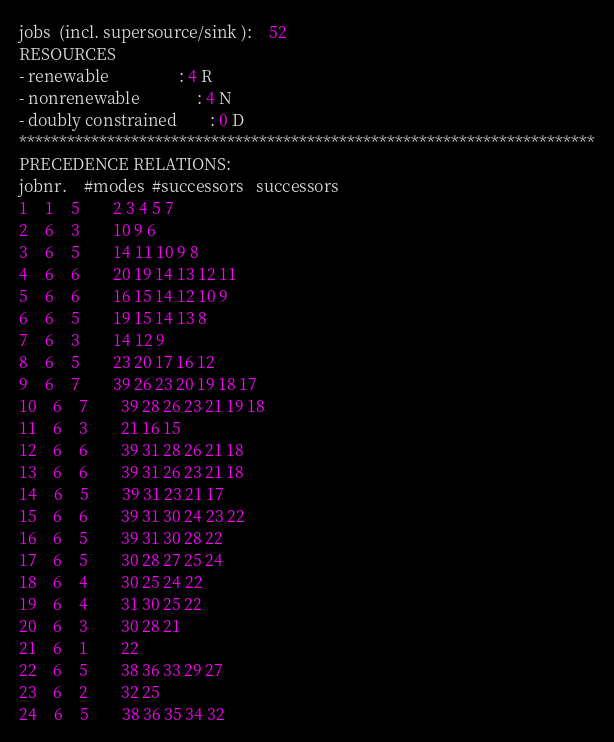<code> <loc_0><loc_0><loc_500><loc_500><_ObjectiveC_>jobs  (incl. supersource/sink ):	52
RESOURCES
- renewable                 : 4 R
- nonrenewable              : 4 N
- doubly constrained        : 0 D
************************************************************************
PRECEDENCE RELATIONS:
jobnr.    #modes  #successors   successors
1	1	5		2 3 4 5 7 
2	6	3		10 9 6 
3	6	5		14 11 10 9 8 
4	6	6		20 19 14 13 12 11 
5	6	6		16 15 14 12 10 9 
6	6	5		19 15 14 13 8 
7	6	3		14 12 9 
8	6	5		23 20 17 16 12 
9	6	7		39 26 23 20 19 18 17 
10	6	7		39 28 26 23 21 19 18 
11	6	3		21 16 15 
12	6	6		39 31 28 26 21 18 
13	6	6		39 31 26 23 21 18 
14	6	5		39 31 23 21 17 
15	6	6		39 31 30 24 23 22 
16	6	5		39 31 30 28 22 
17	6	5		30 28 27 25 24 
18	6	4		30 25 24 22 
19	6	4		31 30 25 22 
20	6	3		30 28 21 
21	6	1		22 
22	6	5		38 36 33 29 27 
23	6	2		32 25 
24	6	5		38 36 35 34 32 </code> 